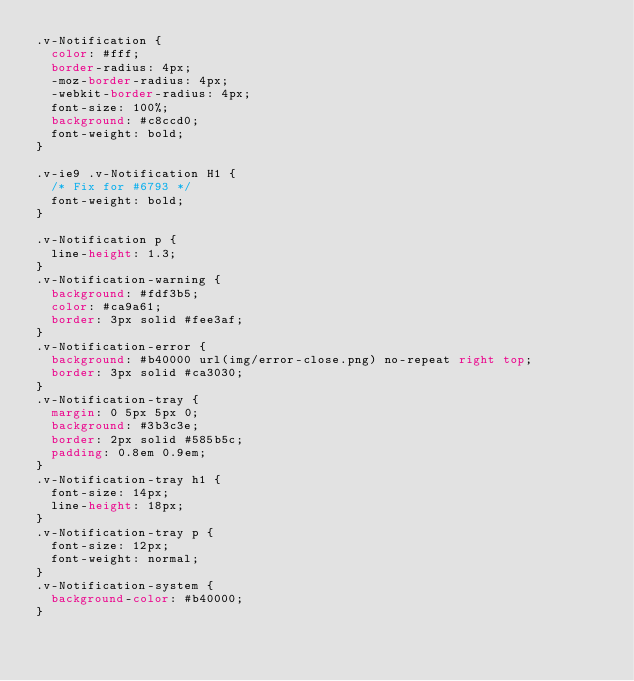<code> <loc_0><loc_0><loc_500><loc_500><_CSS_>.v-Notification {
	color: #fff;
	border-radius: 4px;
	-moz-border-radius: 4px;
	-webkit-border-radius: 4px;
	font-size: 100%;
	background: #c8ccd0;
	font-weight: bold;
}

.v-ie9 .v-Notification H1 {
	/* Fix for #6793 */
	font-weight: bold;
}
	
.v-Notification p {
	line-height: 1.3;
}
.v-Notification-warning {
	background: #fdf3b5;
	color: #ca9a61;
	border: 3px solid #fee3af;
}
.v-Notification-error {
	background: #b40000 url(img/error-close.png) no-repeat right top;
	border: 3px solid #ca3030;
}
.v-Notification-tray {
	margin: 0 5px 5px 0;
	background: #3b3c3e;
	border: 2px solid #585b5c;
	padding: 0.8em 0.9em;
}
.v-Notification-tray h1 {
	font-size: 14px;
	line-height: 18px;
}
.v-Notification-tray p {
	font-size: 12px;
	font-weight: normal;
}
.v-Notification-system {
	background-color: #b40000;
}</code> 